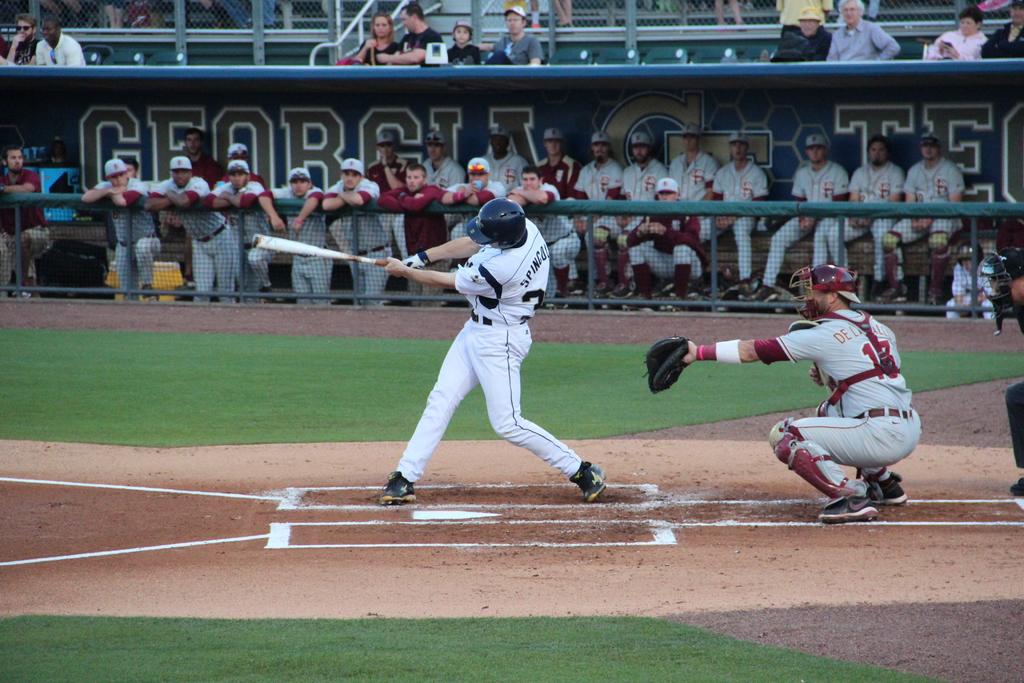What state is this stadium located in?
Give a very brief answer. Georgia. What is the first number in the catcher's player number?
Provide a succinct answer. 1. 